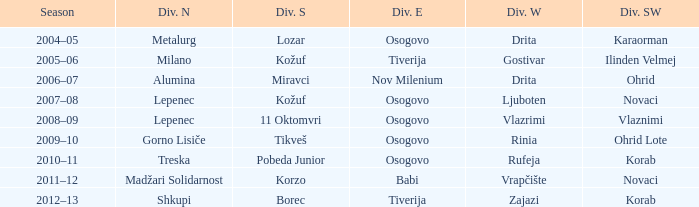Who won Division North when Division Southwest was won by Novaci and Division West by Vrapčište? Madžari Solidarnost. Help me parse the entirety of this table. {'header': ['Season', 'Div. N', 'Div. S', 'Div. E', 'Div. W', 'Div. SW'], 'rows': [['2004–05', 'Metalurg', 'Lozar', 'Osogovo', 'Drita', 'Karaorman'], ['2005–06', 'Milano', 'Kožuf', 'Tiverija', 'Gostivar', 'Ilinden Velmej'], ['2006–07', 'Alumina', 'Miravci', 'Nov Milenium', 'Drita', 'Ohrid'], ['2007–08', 'Lepenec', 'Kožuf', 'Osogovo', 'Ljuboten', 'Novaci'], ['2008–09', 'Lepenec', '11 Oktomvri', 'Osogovo', 'Vlazrimi', 'Vlaznimi'], ['2009–10', 'Gorno Lisiče', 'Tikveš', 'Osogovo', 'Rinia', 'Ohrid Lote'], ['2010–11', 'Treska', 'Pobeda Junior', 'Osogovo', 'Rufeja', 'Korab'], ['2011–12', 'Madžari Solidarnost', 'Korzo', 'Babi', 'Vrapčište', 'Novaci'], ['2012–13', 'Shkupi', 'Borec', 'Tiverija', 'Zajazi', 'Korab']]} 